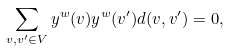Convert formula to latex. <formula><loc_0><loc_0><loc_500><loc_500>\sum _ { v , v ^ { \prime } \in V } y ^ { w } ( v ) y ^ { w } ( v ^ { \prime } ) d ( v , v ^ { \prime } ) = 0 ,</formula> 